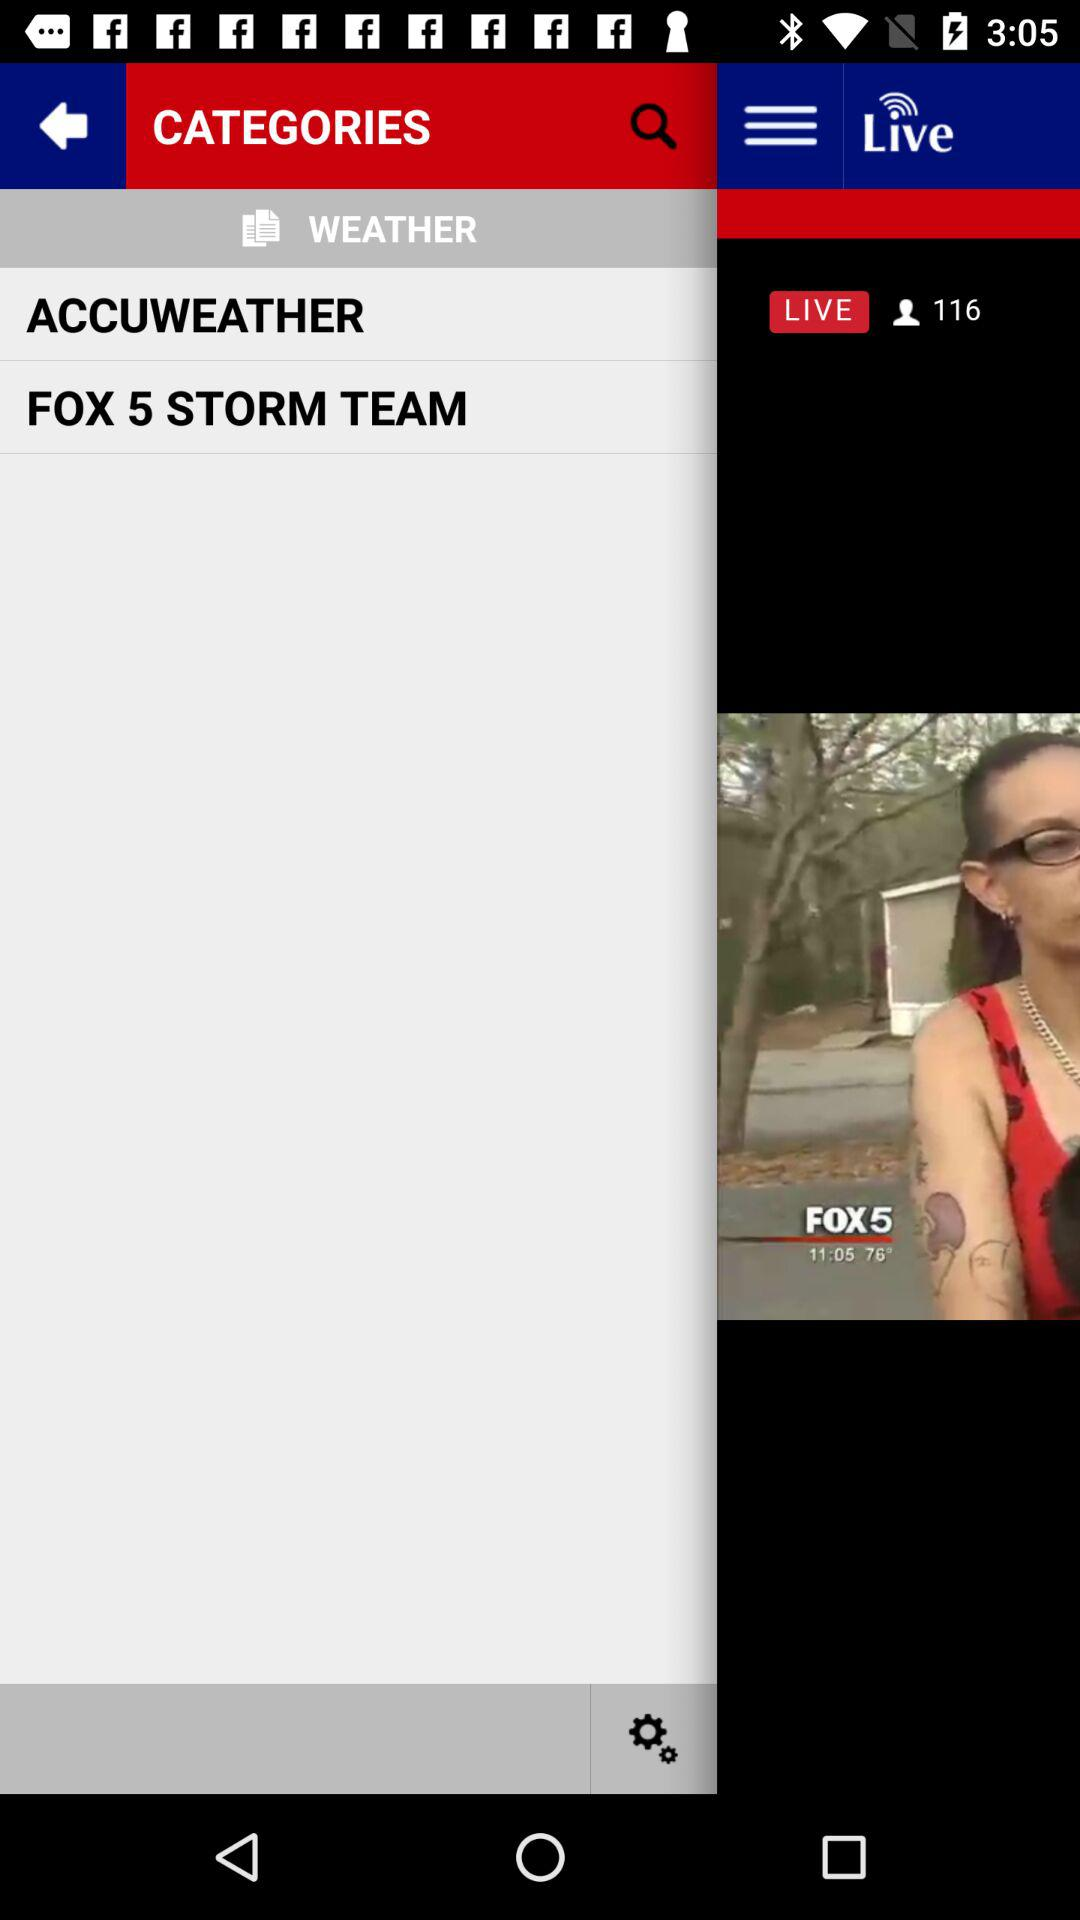What is the name of the woman? The name of the woman is Katrina Jackson. 